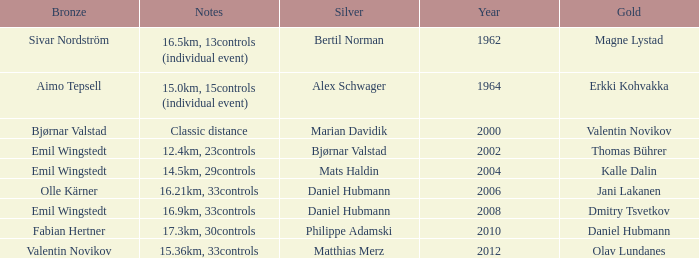WHAT YEAR HAS A BRONZE OF VALENTIN NOVIKOV? 2012.0. 